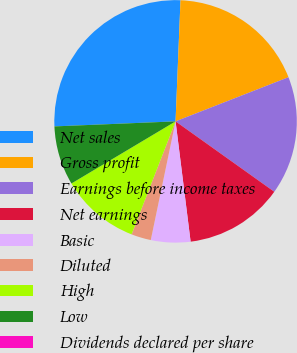Convert chart to OTSL. <chart><loc_0><loc_0><loc_500><loc_500><pie_chart><fcel>Net sales<fcel>Gross profit<fcel>Earnings before income taxes<fcel>Net earnings<fcel>Basic<fcel>Diluted<fcel>High<fcel>Low<fcel>Dividends declared per share<nl><fcel>26.31%<fcel>18.42%<fcel>15.79%<fcel>13.16%<fcel>5.26%<fcel>2.63%<fcel>10.53%<fcel>7.9%<fcel>0.0%<nl></chart> 